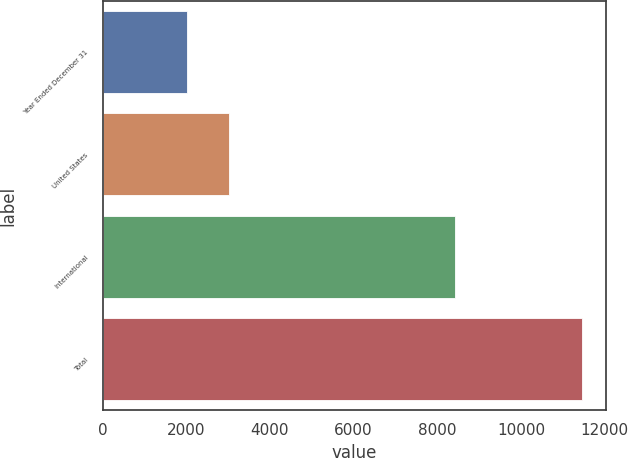Convert chart. <chart><loc_0><loc_0><loc_500><loc_500><bar_chart><fcel>Year Ended December 31<fcel>United States<fcel>International<fcel>Total<nl><fcel>2011<fcel>3029<fcel>8429<fcel>11458<nl></chart> 